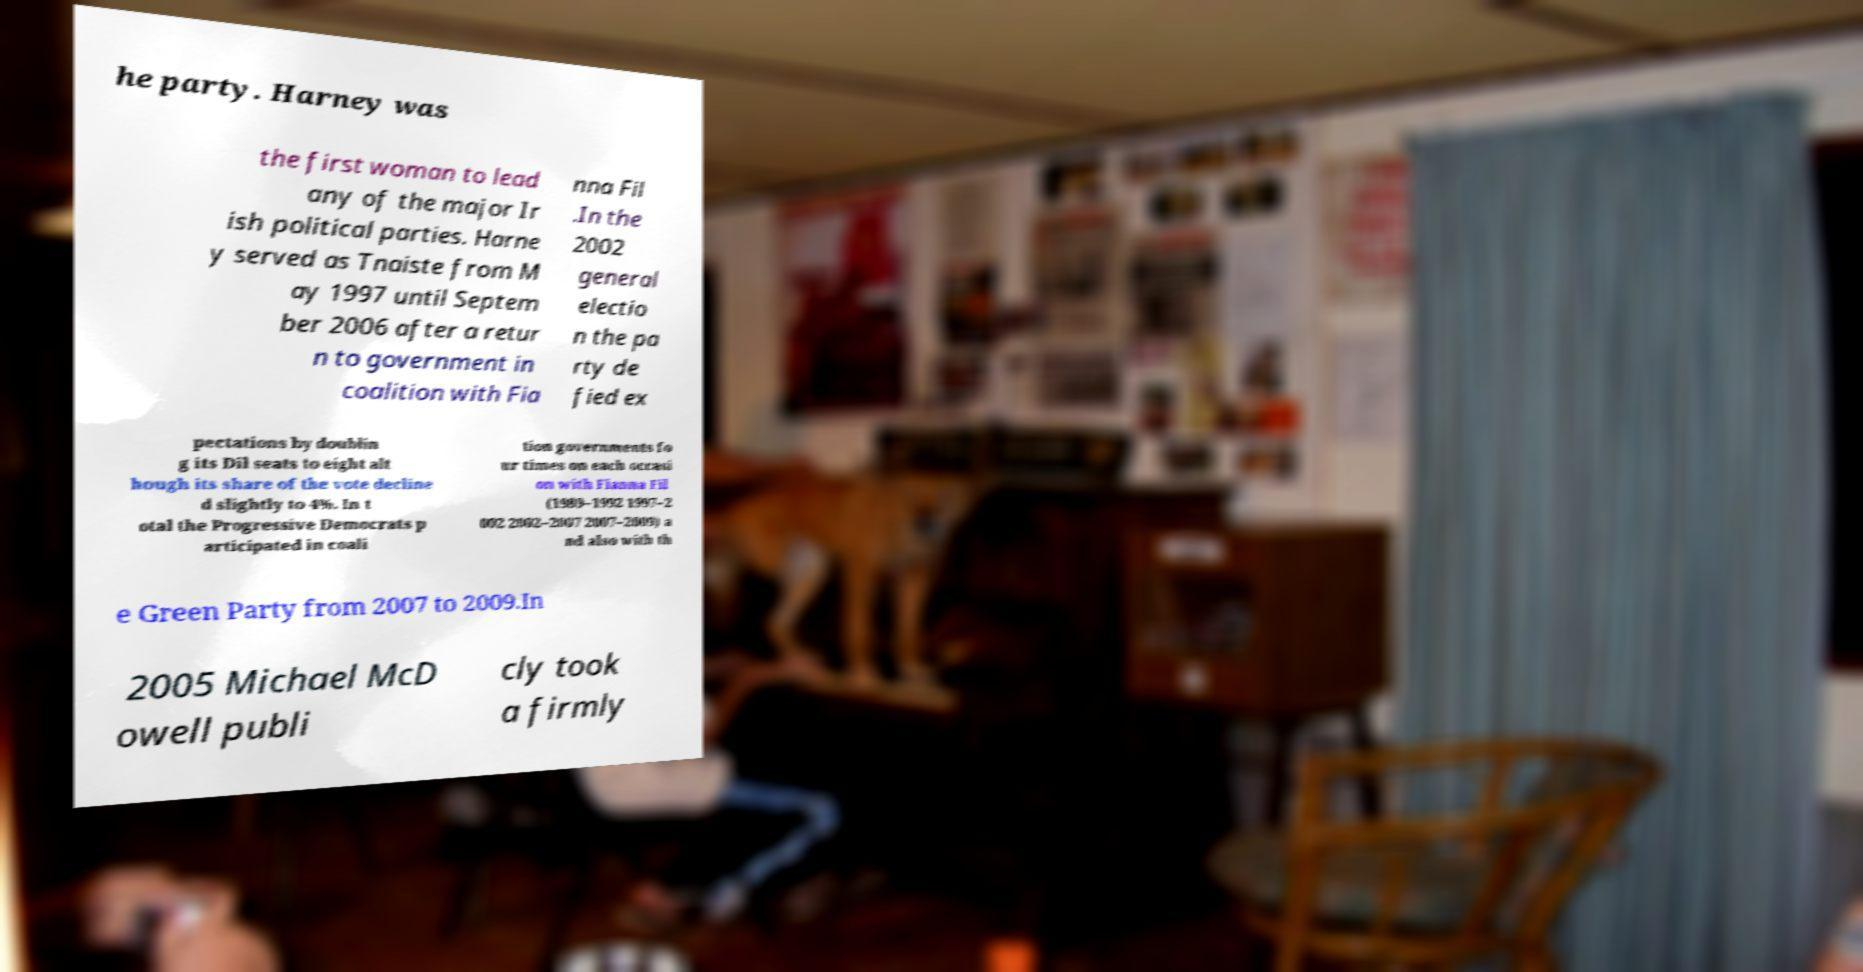Could you extract and type out the text from this image? he party. Harney was the first woman to lead any of the major Ir ish political parties. Harne y served as Tnaiste from M ay 1997 until Septem ber 2006 after a retur n to government in coalition with Fia nna Fil .In the 2002 general electio n the pa rty de fied ex pectations by doublin g its Dil seats to eight alt hough its share of the vote decline d slightly to 4%. In t otal the Progressive Democrats p articipated in coali tion governments fo ur times on each occasi on with Fianna Fil (1989–1992 1997–2 002 2002–2007 2007–2009) a nd also with th e Green Party from 2007 to 2009.In 2005 Michael McD owell publi cly took a firmly 